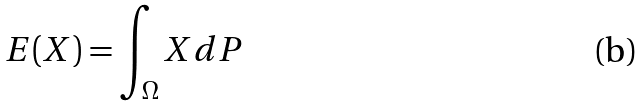<formula> <loc_0><loc_0><loc_500><loc_500>E ( X ) = \int _ { \Omega } X d P</formula> 